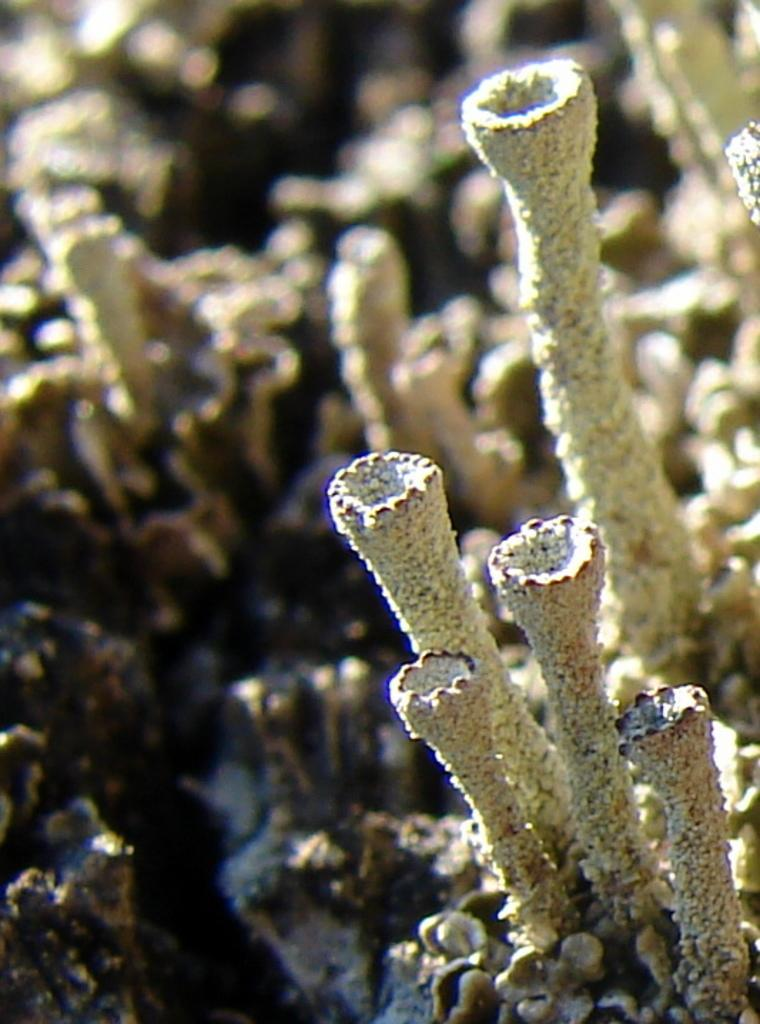What type of plant is visible in the image? There is a marine plant in the image. How many stars can be seen on the bed in the image? There is no bed or stars present in the image; it features a marine plant. Is the marine plant swimming in the image? The marine plant is not swimming in the image; it is stationary. 